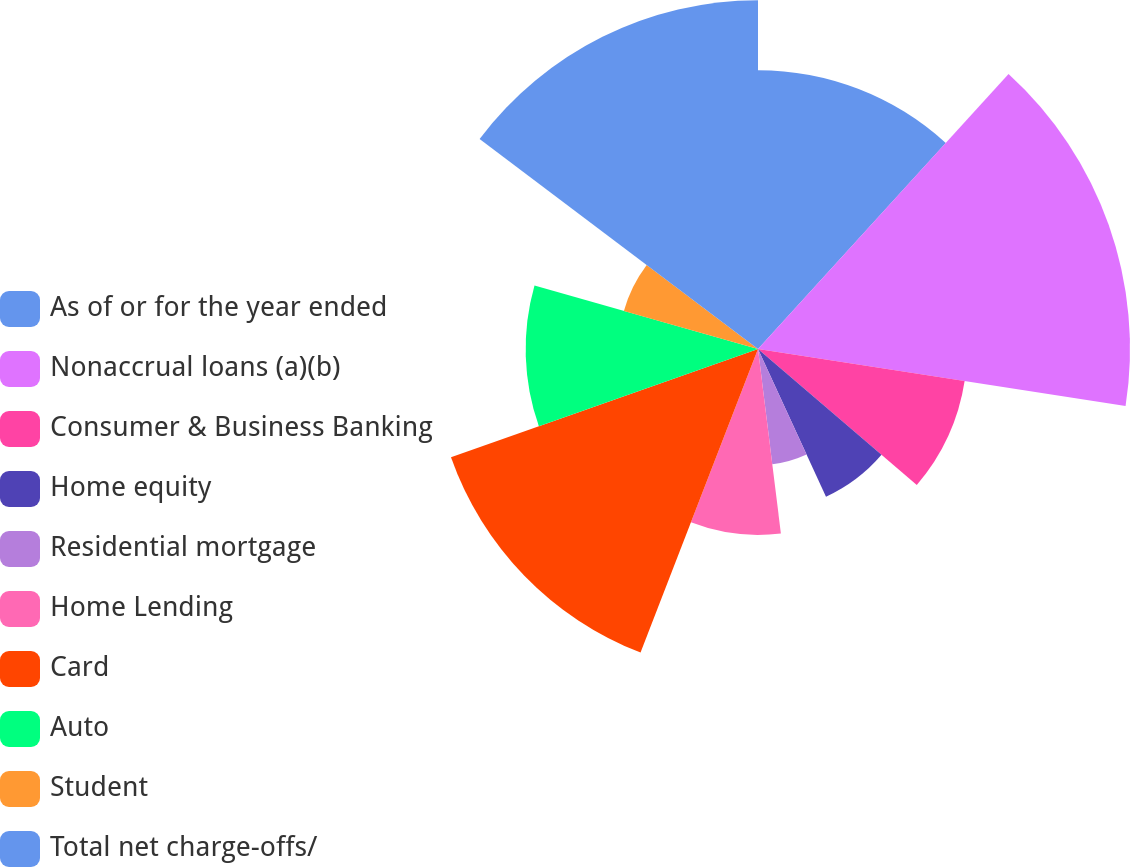Convert chart. <chart><loc_0><loc_0><loc_500><loc_500><pie_chart><fcel>As of or for the year ended<fcel>Nonaccrual loans (a)(b)<fcel>Consumer & Business Banking<fcel>Home equity<fcel>Residential mortgage<fcel>Home Lending<fcel>Card<fcel>Auto<fcel>Student<fcel>Total net charge-offs/<nl><fcel>11.76%<fcel>15.69%<fcel>8.82%<fcel>6.86%<fcel>4.9%<fcel>7.84%<fcel>13.73%<fcel>9.8%<fcel>5.88%<fcel>14.71%<nl></chart> 